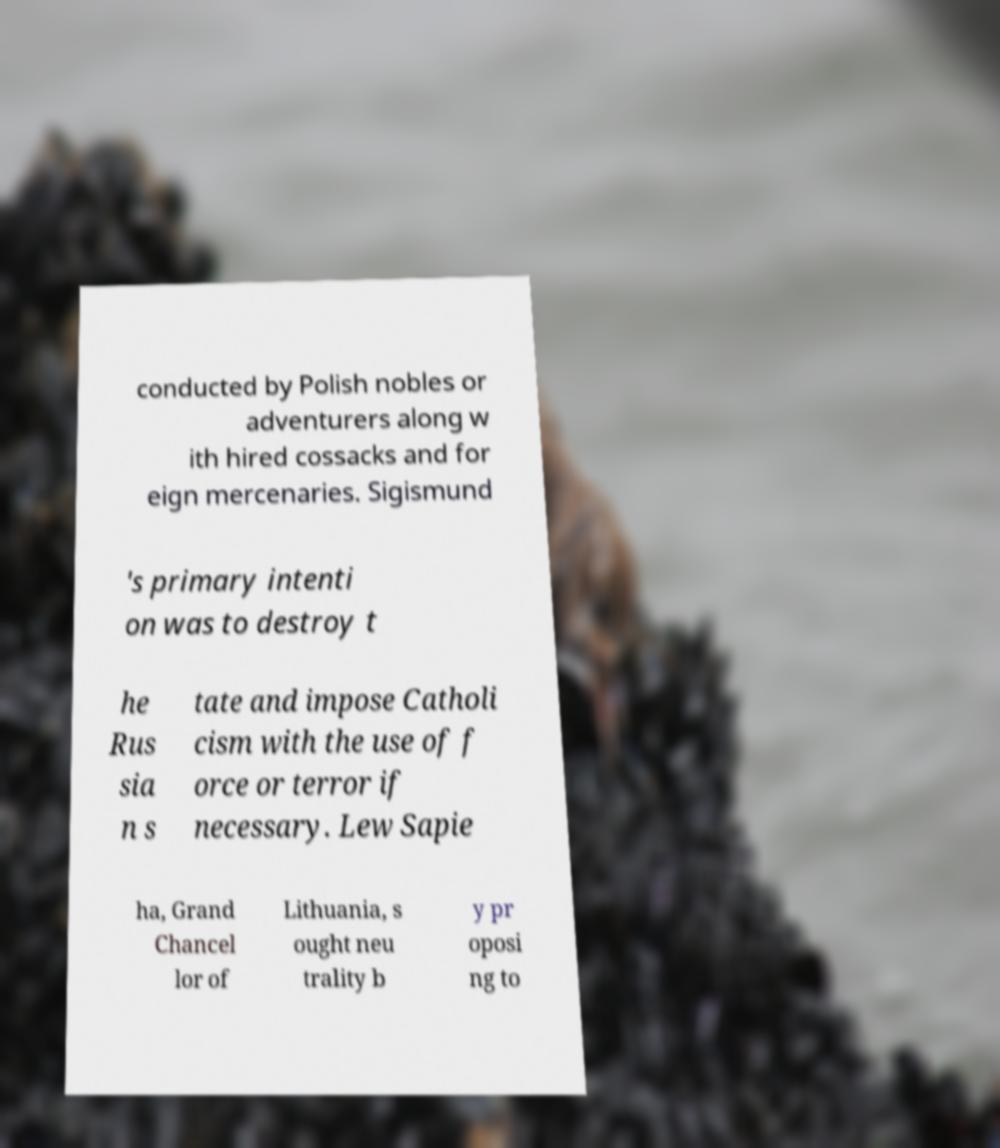Could you extract and type out the text from this image? conducted by Polish nobles or adventurers along w ith hired cossacks and for eign mercenaries. Sigismund 's primary intenti on was to destroy t he Rus sia n s tate and impose Catholi cism with the use of f orce or terror if necessary. Lew Sapie ha, Grand Chancel lor of Lithuania, s ought neu trality b y pr oposi ng to 